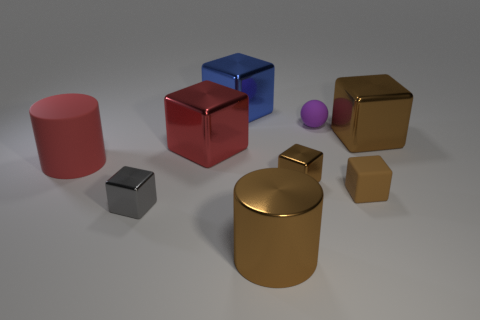Subtract all small brown rubber cubes. How many cubes are left? 5 Add 1 large green rubber cylinders. How many objects exist? 10 Subtract all blocks. How many objects are left? 3 Subtract all cubes. Subtract all big blue metallic things. How many objects are left? 2 Add 5 tiny matte things. How many tiny matte things are left? 7 Add 9 large red matte cylinders. How many large red matte cylinders exist? 10 Subtract all red cylinders. How many cylinders are left? 1 Subtract 0 purple cubes. How many objects are left? 9 Subtract all cyan cylinders. Subtract all yellow spheres. How many cylinders are left? 2 Subtract all purple spheres. How many red cylinders are left? 1 